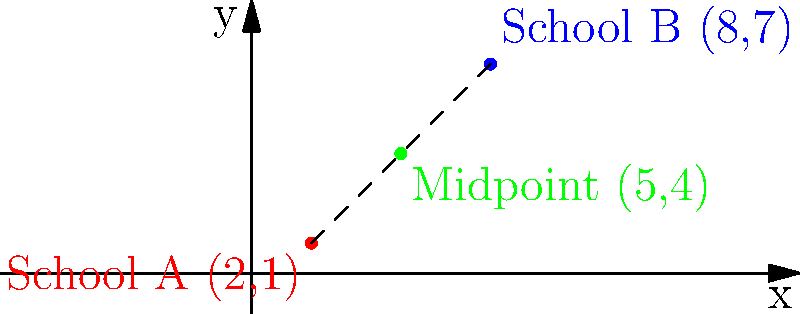As part of an initiative to promote diversity and inclusion, you're planning a joint storytime event for two schools with different demographic profiles. School A is located at coordinates (2,1), and School B is at (8,7). To ensure equal accessibility, you want to host the event at the midpoint between these schools. Calculate the coordinates of this midpoint. To find the midpoint between two points, we use the midpoint formula:

$$ \text{Midpoint} = \left(\frac{x_1 + x_2}{2}, \frac{y_1 + y_2}{2}\right) $$

Where $(x_1, y_1)$ are the coordinates of the first point and $(x_2, y_2)$ are the coordinates of the second point.

For our problem:
School A: $(x_1, y_1) = (2, 1)$
School B: $(x_2, y_2) = (8, 7)$

Let's calculate the x-coordinate of the midpoint:
$$ x = \frac{x_1 + x_2}{2} = \frac{2 + 8}{2} = \frac{10}{2} = 5 $$

Now, let's calculate the y-coordinate of the midpoint:
$$ y = \frac{y_1 + y_2}{2} = \frac{1 + 7}{2} = \frac{8}{2} = 4 $$

Therefore, the midpoint coordinates are (5, 4).
Answer: (5, 4) 